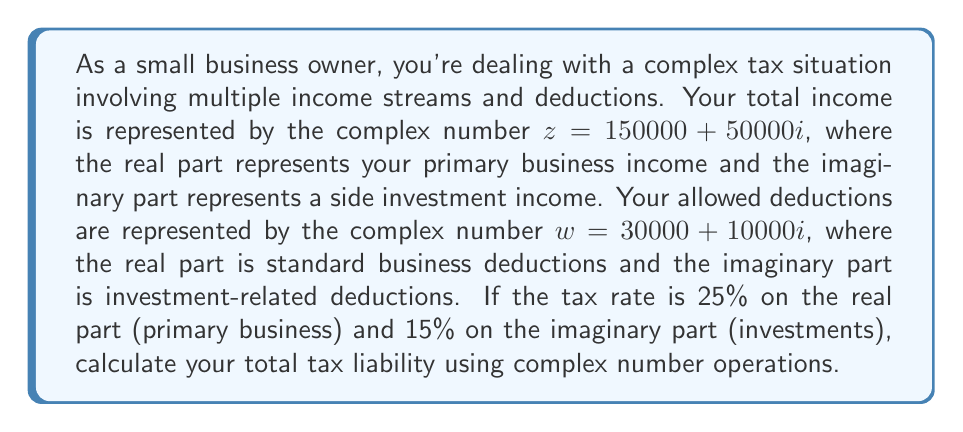Solve this math problem. To solve this problem, we'll follow these steps:

1) First, we need to subtract the deductions from the income:
   $$z - w = (150000 + 50000i) - (30000 + 10000i)$$
   $$= (150000 - 30000) + (50000 - 10000)i$$
   $$= 120000 + 40000i$$

2) Now, we need to apply the different tax rates to the real and imaginary parts. Let's call our tax liability $T$:
   $$T = 0.25(120000) + 0.15(40000)i$$
   $$= 30000 + 6000i$$

3) To get the total tax liability, we need to find the magnitude of this complex number:
   $$|T| = \sqrt{(30000)^2 + (6000)^2}$$
   $$= \sqrt{900000000 + 36000000}$$
   $$= \sqrt{936000000}$$
   $$= 30594.12$$ (rounded to two decimal places)

Therefore, the total tax liability is $30,594.12.
Answer: $30,594.12 